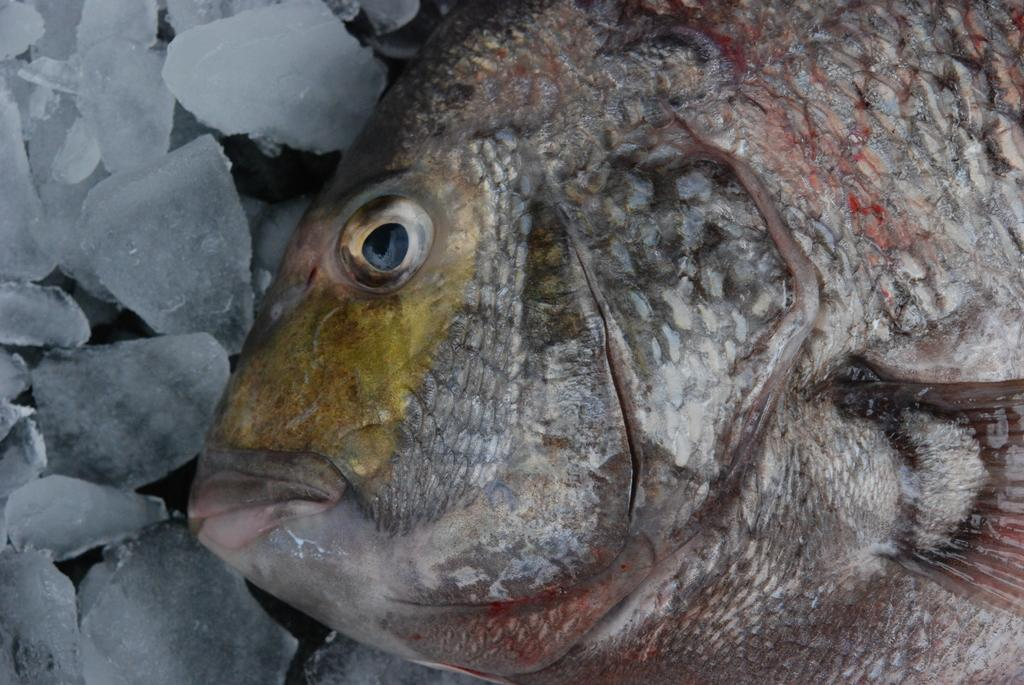What is the main subject in the foreground of the image? There is a truncated fish in the foreground of the image. What is the fish placed on in the image? The fish is on the ice. What type of wrist accessory is visible on the fish in the image? There is no wrist accessory present on the fish in the image. What word is written on the fish in the image? There are no words written on the fish in the image. How many cabbages are visible in the image? There are no cabbages present in the image. 